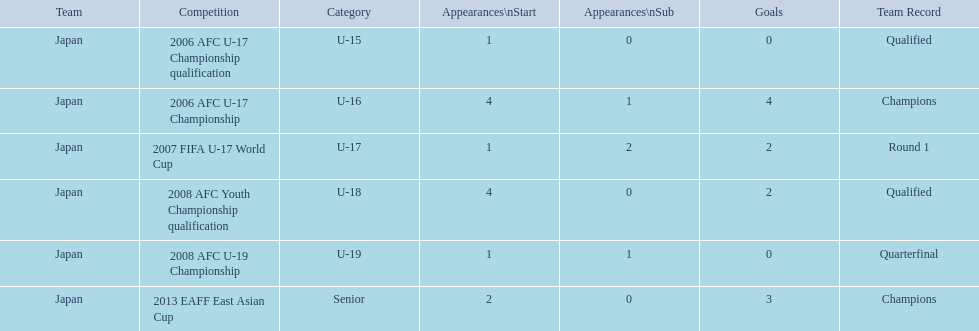In which events did the winning teams set records? 2006 AFC U-17 Championship, 2013 EAFF East Asian Cup. Of these events, which one was in the senior level? 2013 EAFF East Asian Cup. 